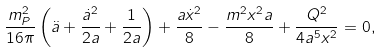<formula> <loc_0><loc_0><loc_500><loc_500>\frac { m _ { P } ^ { 2 } } { 1 6 \pi } \left ( \ddot { a } + \frac { { \dot { a } } ^ { 2 } } { 2 a } + \frac { 1 } { 2 a } \right ) + \frac { a { \dot { x } } ^ { 2 } } { 8 } - \frac { m ^ { 2 } x ^ { 2 } a } { 8 } + \frac { Q ^ { 2 } } { 4 a ^ { 5 } x ^ { 2 } } = 0 ,</formula> 